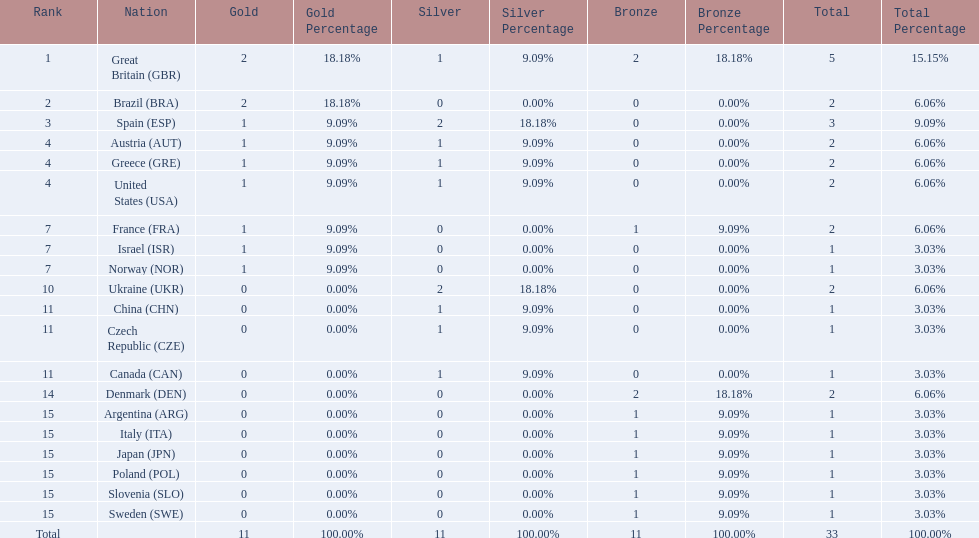What are all of the countries? Great Britain (GBR), Brazil (BRA), Spain (ESP), Austria (AUT), Greece (GRE), United States (USA), France (FRA), Israel (ISR), Norway (NOR), Ukraine (UKR), China (CHN), Czech Republic (CZE), Canada (CAN), Denmark (DEN), Argentina (ARG), Italy (ITA), Japan (JPN), Poland (POL), Slovenia (SLO), Sweden (SWE). Which ones earned a medal? Great Britain (GBR), Brazil (BRA), Spain (ESP), Austria (AUT), Greece (GRE), United States (USA), France (FRA), Israel (ISR), Norway (NOR), Ukraine (UKR), China (CHN), Czech Republic (CZE), Canada (CAN), Denmark (DEN), Argentina (ARG), Italy (ITA), Japan (JPN), Poland (POL), Slovenia (SLO), Sweden (SWE). Which countries earned at least 3 medals? Great Britain (GBR), Spain (ESP). Which country earned 3 medals? Spain (ESP). 